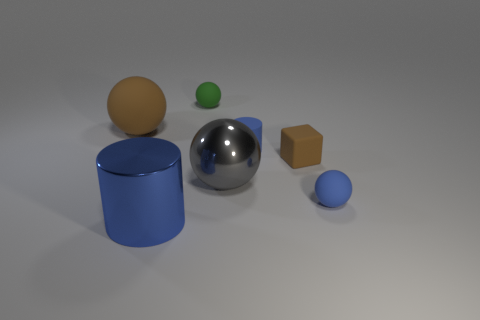Add 3 small purple cubes. How many objects exist? 10 Subtract all green balls. How many balls are left? 3 Subtract all brown rubber balls. How many balls are left? 3 Subtract all spheres. How many objects are left? 3 Subtract all gray metal objects. Subtract all gray metal balls. How many objects are left? 5 Add 5 green rubber spheres. How many green rubber spheres are left? 6 Add 2 big green shiny spheres. How many big green shiny spheres exist? 2 Subtract 2 blue cylinders. How many objects are left? 5 Subtract 1 blocks. How many blocks are left? 0 Subtract all red cubes. Subtract all purple spheres. How many cubes are left? 1 